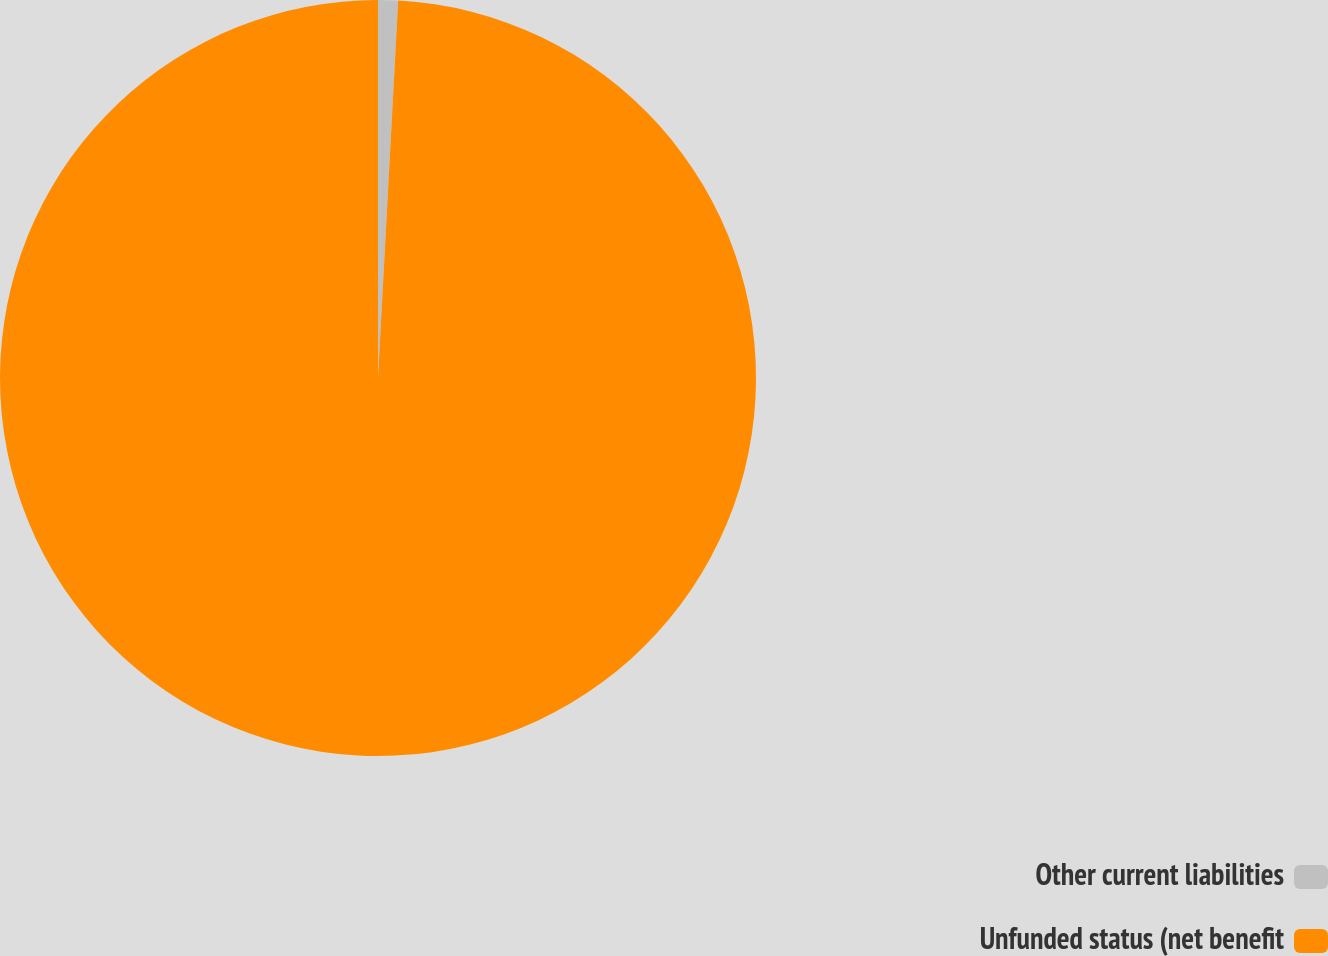Convert chart to OTSL. <chart><loc_0><loc_0><loc_500><loc_500><pie_chart><fcel>Other current liabilities<fcel>Unfunded status (net benefit<nl><fcel>0.85%<fcel>99.15%<nl></chart> 